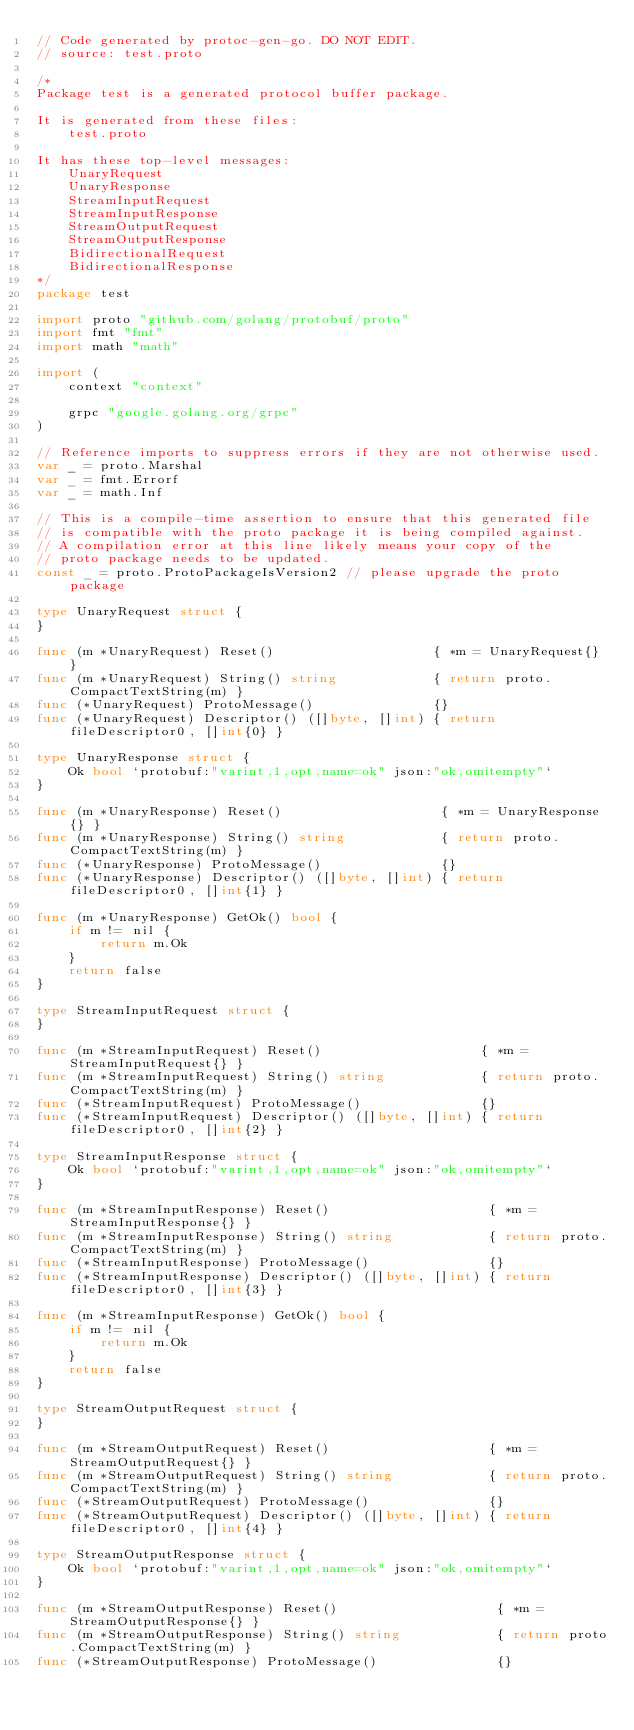Convert code to text. <code><loc_0><loc_0><loc_500><loc_500><_Go_>// Code generated by protoc-gen-go. DO NOT EDIT.
// source: test.proto

/*
Package test is a generated protocol buffer package.

It is generated from these files:
	test.proto

It has these top-level messages:
	UnaryRequest
	UnaryResponse
	StreamInputRequest
	StreamInputResponse
	StreamOutputRequest
	StreamOutputResponse
	BidirectionalRequest
	BidirectionalResponse
*/
package test

import proto "github.com/golang/protobuf/proto"
import fmt "fmt"
import math "math"

import (
	context "context"

	grpc "google.golang.org/grpc"
)

// Reference imports to suppress errors if they are not otherwise used.
var _ = proto.Marshal
var _ = fmt.Errorf
var _ = math.Inf

// This is a compile-time assertion to ensure that this generated file
// is compatible with the proto package it is being compiled against.
// A compilation error at this line likely means your copy of the
// proto package needs to be updated.
const _ = proto.ProtoPackageIsVersion2 // please upgrade the proto package

type UnaryRequest struct {
}

func (m *UnaryRequest) Reset()                    { *m = UnaryRequest{} }
func (m *UnaryRequest) String() string            { return proto.CompactTextString(m) }
func (*UnaryRequest) ProtoMessage()               {}
func (*UnaryRequest) Descriptor() ([]byte, []int) { return fileDescriptor0, []int{0} }

type UnaryResponse struct {
	Ok bool `protobuf:"varint,1,opt,name=ok" json:"ok,omitempty"`
}

func (m *UnaryResponse) Reset()                    { *m = UnaryResponse{} }
func (m *UnaryResponse) String() string            { return proto.CompactTextString(m) }
func (*UnaryResponse) ProtoMessage()               {}
func (*UnaryResponse) Descriptor() ([]byte, []int) { return fileDescriptor0, []int{1} }

func (m *UnaryResponse) GetOk() bool {
	if m != nil {
		return m.Ok
	}
	return false
}

type StreamInputRequest struct {
}

func (m *StreamInputRequest) Reset()                    { *m = StreamInputRequest{} }
func (m *StreamInputRequest) String() string            { return proto.CompactTextString(m) }
func (*StreamInputRequest) ProtoMessage()               {}
func (*StreamInputRequest) Descriptor() ([]byte, []int) { return fileDescriptor0, []int{2} }

type StreamInputResponse struct {
	Ok bool `protobuf:"varint,1,opt,name=ok" json:"ok,omitempty"`
}

func (m *StreamInputResponse) Reset()                    { *m = StreamInputResponse{} }
func (m *StreamInputResponse) String() string            { return proto.CompactTextString(m) }
func (*StreamInputResponse) ProtoMessage()               {}
func (*StreamInputResponse) Descriptor() ([]byte, []int) { return fileDescriptor0, []int{3} }

func (m *StreamInputResponse) GetOk() bool {
	if m != nil {
		return m.Ok
	}
	return false
}

type StreamOutputRequest struct {
}

func (m *StreamOutputRequest) Reset()                    { *m = StreamOutputRequest{} }
func (m *StreamOutputRequest) String() string            { return proto.CompactTextString(m) }
func (*StreamOutputRequest) ProtoMessage()               {}
func (*StreamOutputRequest) Descriptor() ([]byte, []int) { return fileDescriptor0, []int{4} }

type StreamOutputResponse struct {
	Ok bool `protobuf:"varint,1,opt,name=ok" json:"ok,omitempty"`
}

func (m *StreamOutputResponse) Reset()                    { *m = StreamOutputResponse{} }
func (m *StreamOutputResponse) String() string            { return proto.CompactTextString(m) }
func (*StreamOutputResponse) ProtoMessage()               {}</code> 